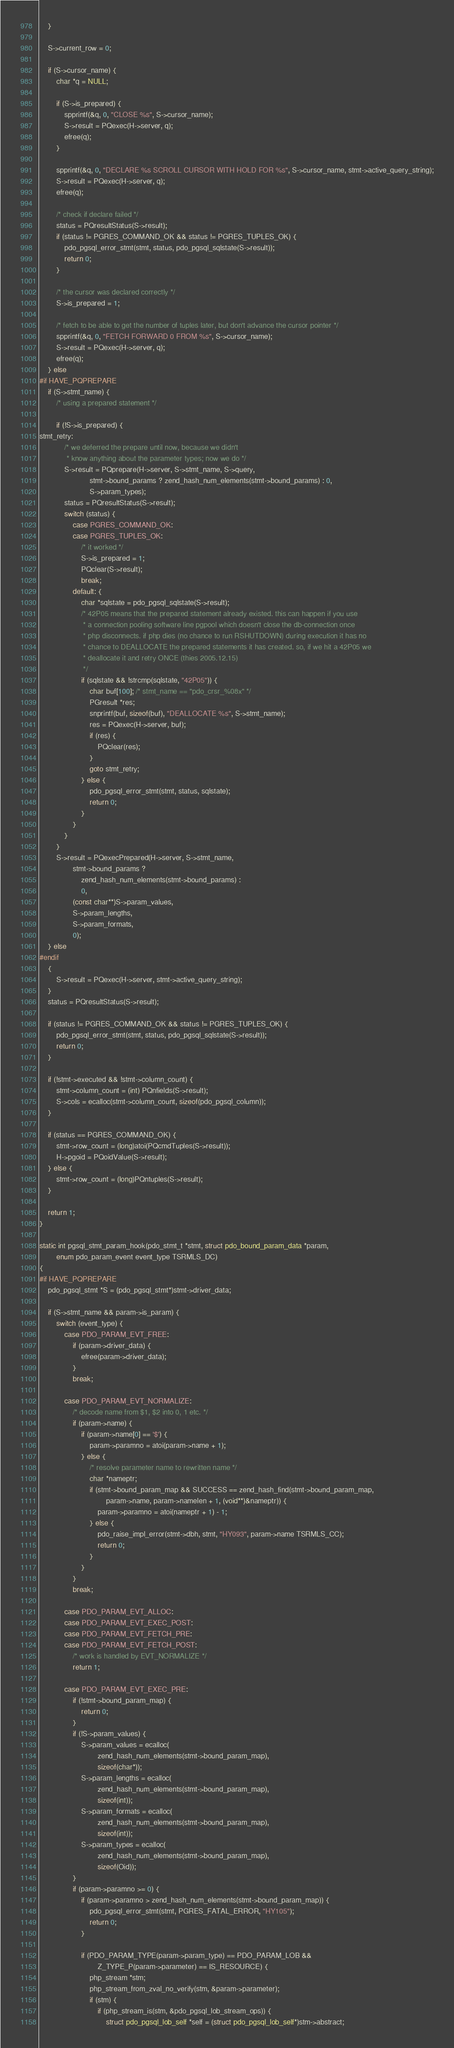Convert code to text. <code><loc_0><loc_0><loc_500><loc_500><_C_>	}
	
	S->current_row = 0;

	if (S->cursor_name) {
		char *q = NULL;

		if (S->is_prepared) {
			spprintf(&q, 0, "CLOSE %s", S->cursor_name);
			S->result = PQexec(H->server, q);
			efree(q);
		}

		spprintf(&q, 0, "DECLARE %s SCROLL CURSOR WITH HOLD FOR %s", S->cursor_name, stmt->active_query_string);
		S->result = PQexec(H->server, q);
		efree(q);

		/* check if declare failed */
		status = PQresultStatus(S->result);
		if (status != PGRES_COMMAND_OK && status != PGRES_TUPLES_OK) {
			pdo_pgsql_error_stmt(stmt, status, pdo_pgsql_sqlstate(S->result));
			return 0;
		}

		/* the cursor was declared correctly */
		S->is_prepared = 1;

		/* fetch to be able to get the number of tuples later, but don't advance the cursor pointer */
		spprintf(&q, 0, "FETCH FORWARD 0 FROM %s", S->cursor_name);
		S->result = PQexec(H->server, q);
		efree(q);
	} else
#if HAVE_PQPREPARE
	if (S->stmt_name) {
		/* using a prepared statement */

		if (!S->is_prepared) {
stmt_retry:
			/* we deferred the prepare until now, because we didn't
			 * know anything about the parameter types; now we do */
			S->result = PQprepare(H->server, S->stmt_name, S->query, 
						stmt->bound_params ? zend_hash_num_elements(stmt->bound_params) : 0,
						S->param_types);
			status = PQresultStatus(S->result);
			switch (status) {
				case PGRES_COMMAND_OK:
				case PGRES_TUPLES_OK:
					/* it worked */
					S->is_prepared = 1;
					PQclear(S->result);
					break;
				default: {
					char *sqlstate = pdo_pgsql_sqlstate(S->result);
					/* 42P05 means that the prepared statement already existed. this can happen if you use 
					 * a connection pooling software line pgpool which doesn't close the db-connection once 
					 * php disconnects. if php dies (no chance to run RSHUTDOWN) during execution it has no 
					 * chance to DEALLOCATE the prepared statements it has created. so, if we hit a 42P05 we 
					 * deallocate it and retry ONCE (thies 2005.12.15)
					 */
					if (sqlstate && !strcmp(sqlstate, "42P05")) {
						char buf[100]; /* stmt_name == "pdo_crsr_%08x" */
						PGresult *res;
						snprintf(buf, sizeof(buf), "DEALLOCATE %s", S->stmt_name);
						res = PQexec(H->server, buf);
						if (res) {
							PQclear(res);
						}
						goto stmt_retry;
					} else {
						pdo_pgsql_error_stmt(stmt, status, sqlstate);
						return 0;
					}
				}
			}
		}
		S->result = PQexecPrepared(H->server, S->stmt_name,
				stmt->bound_params ?
					zend_hash_num_elements(stmt->bound_params) :
					0,
				(const char**)S->param_values,
				S->param_lengths,
				S->param_formats,
				0);
	} else
#endif
	{
		S->result = PQexec(H->server, stmt->active_query_string);
	}
	status = PQresultStatus(S->result);

	if (status != PGRES_COMMAND_OK && status != PGRES_TUPLES_OK) {
		pdo_pgsql_error_stmt(stmt, status, pdo_pgsql_sqlstate(S->result));
		return 0;
	}

	if (!stmt->executed && !stmt->column_count) {
		stmt->column_count = (int) PQnfields(S->result);
		S->cols = ecalloc(stmt->column_count, sizeof(pdo_pgsql_column));
	}

	if (status == PGRES_COMMAND_OK) {
		stmt->row_count = (long)atoi(PQcmdTuples(S->result));
		H->pgoid = PQoidValue(S->result);
	} else {
		stmt->row_count = (long)PQntuples(S->result);
	}

	return 1;
}

static int pgsql_stmt_param_hook(pdo_stmt_t *stmt, struct pdo_bound_param_data *param,
		enum pdo_param_event event_type TSRMLS_DC)
{
#if HAVE_PQPREPARE
	pdo_pgsql_stmt *S = (pdo_pgsql_stmt*)stmt->driver_data;

	if (S->stmt_name && param->is_param) {
		switch (event_type) {
			case PDO_PARAM_EVT_FREE:
				if (param->driver_data) {
					efree(param->driver_data);
				}
				break;

			case PDO_PARAM_EVT_NORMALIZE:
				/* decode name from $1, $2 into 0, 1 etc. */
				if (param->name) {
					if (param->name[0] == '$') {
						param->paramno = atoi(param->name + 1);
					} else {
						/* resolve parameter name to rewritten name */
						char *nameptr;
						if (stmt->bound_param_map && SUCCESS == zend_hash_find(stmt->bound_param_map,
								param->name, param->namelen + 1, (void**)&nameptr)) {
							param->paramno = atoi(nameptr + 1) - 1;
						} else {
							pdo_raise_impl_error(stmt->dbh, stmt, "HY093", param->name TSRMLS_CC);
							return 0;
						}
					}
				}
				break;

			case PDO_PARAM_EVT_ALLOC:
			case PDO_PARAM_EVT_EXEC_POST:
			case PDO_PARAM_EVT_FETCH_PRE:
			case PDO_PARAM_EVT_FETCH_POST:
				/* work is handled by EVT_NORMALIZE */
				return 1;

			case PDO_PARAM_EVT_EXEC_PRE:
				if (!stmt->bound_param_map) {
					return 0;
				}
				if (!S->param_values) {
					S->param_values = ecalloc(
							zend_hash_num_elements(stmt->bound_param_map),
							sizeof(char*));
					S->param_lengths = ecalloc(
							zend_hash_num_elements(stmt->bound_param_map),
							sizeof(int));
					S->param_formats = ecalloc(
							zend_hash_num_elements(stmt->bound_param_map),
							sizeof(int));
					S->param_types = ecalloc(
							zend_hash_num_elements(stmt->bound_param_map),
							sizeof(Oid));
				}
				if (param->paramno >= 0) {
					if (param->paramno > zend_hash_num_elements(stmt->bound_param_map)) {
						pdo_pgsql_error_stmt(stmt, PGRES_FATAL_ERROR, "HY105");
						return 0;
					}

					if (PDO_PARAM_TYPE(param->param_type) == PDO_PARAM_LOB &&
							Z_TYPE_P(param->parameter) == IS_RESOURCE) {
						php_stream *stm;
						php_stream_from_zval_no_verify(stm, &param->parameter);
						if (stm) {
							if (php_stream_is(stm, &pdo_pgsql_lob_stream_ops)) {
								struct pdo_pgsql_lob_self *self = (struct pdo_pgsql_lob_self*)stm->abstract;</code> 